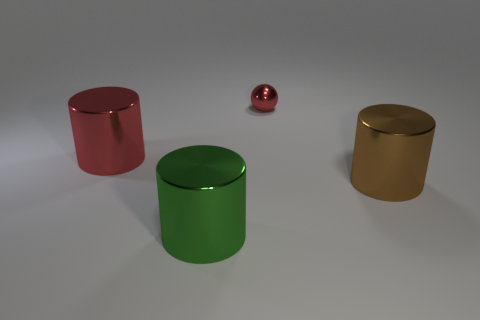There is a brown thing that is the same shape as the green metal object; what material is it?
Offer a terse response. Metal. The large object that is on the left side of the big shiny cylinder that is in front of the big brown thing is what shape?
Keep it short and to the point. Cylinder. Is the large thing that is in front of the big brown metallic cylinder made of the same material as the large red object?
Provide a short and direct response. Yes. Is the number of small red shiny objects to the left of the ball the same as the number of big green metallic things that are behind the big green shiny cylinder?
Provide a short and direct response. Yes. How many metallic things are in front of the big metal cylinder behind the brown cylinder?
Give a very brief answer. 2. There is a shiny object left of the green thing; does it have the same color as the metallic cylinder that is right of the green shiny thing?
Give a very brief answer. No. There is a green cylinder that is the same size as the brown shiny cylinder; what is it made of?
Your answer should be compact. Metal. There is a small metallic object that is behind the metallic cylinder on the right side of the thing that is behind the large red metallic cylinder; what is its shape?
Ensure brevity in your answer.  Sphere. There is a green object that is the same size as the brown cylinder; what shape is it?
Provide a short and direct response. Cylinder. There is a cylinder to the right of the red shiny sphere that is right of the red cylinder; how many small shiny spheres are in front of it?
Offer a very short reply. 0. 